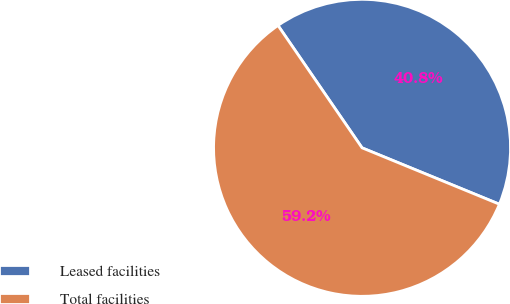Convert chart. <chart><loc_0><loc_0><loc_500><loc_500><pie_chart><fcel>Leased facilities<fcel>Total facilities<nl><fcel>40.78%<fcel>59.22%<nl></chart> 